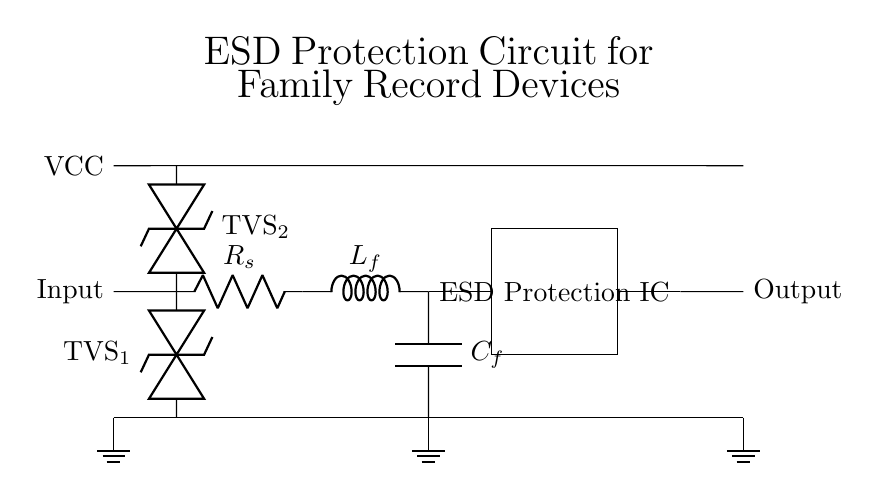What are the two types of diodes used in the circuit? The circuit contains two types of transient voltage suppression diodes labeled as TVS1 and TVS2, which are used for ESD protection.
Answer: TVS diodes What component connects the input to the TVS diode? The input is connected to the TVS diode through a short wire, indicating a direct connection without any resistance.
Answer: Short wire What is the purpose of the LC filter in this circuit? The LC filter consisting of an inductor (L_f) and a capacitor (C_f) is used to smooth out voltage spikes and reduce high-frequency noise, providing additional protection.
Answer: Smoothing voltage What is the function of the ESD Protection IC? The ESD Protection Integrated Circuit is designed to protect the downstream electronics from electrostatic discharges, ensuring safe operation by diverting excess voltage.
Answer: Divert excess voltage How many ground symbols are present in the circuit? There are three ground symbols located at different points in the circuit, indicating common voltage reference points.
Answer: Three What is the significance of the series resistor labeled R_s in the circuit? The series resistor is included to limit the current flowing into the circuit during an ESD event, thereby protecting sensitive components from damage.
Answer: Current limiting What is the VCC label indicating in this circuit? The VCC label indicates the positive supply voltage for the circuit, providing the necessary power for operation to the components within the circuit.
Answer: Positive supply voltage 